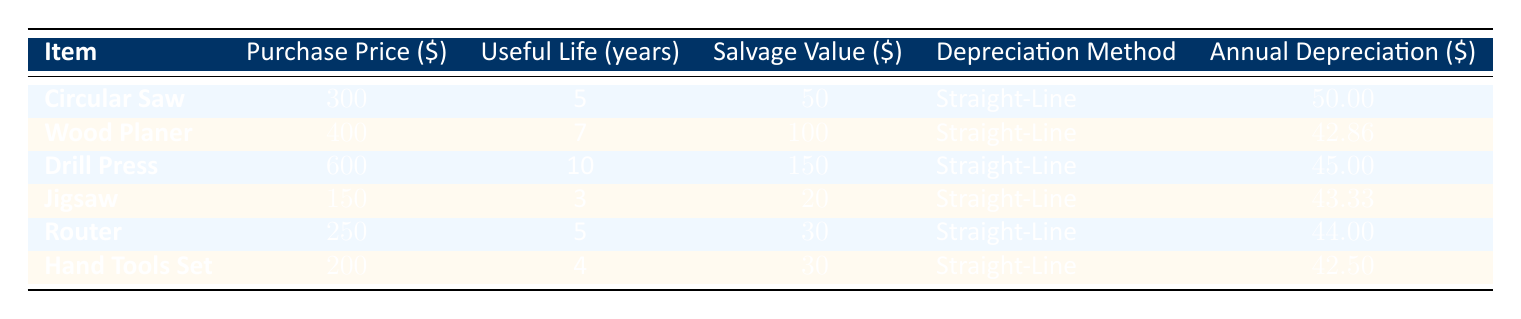What is the purchase price of the Circular Saw? The table lists the Circular Saw under the "Item" column with its corresponding information. The purchase price is provided in the "Purchase Price" column, which shows 300.
Answer: 300 What is the useful life of the Wood Planer? The Wood Planer is listed in the table, and its useful life can be found in the "Useful Life" column, which indicates a value of 7 years.
Answer: 7 years Which item has the highest annual depreciation? To determine the item with the highest annual depreciation, we compare the values in the "Annual Depreciation" column. The Circular Saw has an annual depreciation of 50, which is the highest among the listed items.
Answer: Circular Saw Is the salvage value of the Drill Press more than its annual depreciation? The salvage value of the Drill Press is 150, while its annual depreciation is 45. Since 150 is greater than 45, the statement is true.
Answer: Yes What is the total annual depreciation of all the tools and equipment? To find the total annual depreciation, we sum all the values in the "Annual Depreciation" column: 50 + 42.86 + 45 + 43.33 + 44 + 42.5 = 268.69. Thus, the total annual depreciation is 268.69.
Answer: 268.69 Which tool has the shortest useful life, and what is that duration? By examining the "Useful Life" column, the Jigsaw has the shortest useful life at 3 years, making it the item with the least duration.
Answer: Jigsaw, 3 years What would be the averaged annual depreciation of the tools? To find the average annual depreciation, we take the total annual depreciation of 268.69 and divide it by the number of items (6): 268.69 / 6 = approximately 44.78.
Answer: 44.78 Does the Router have a shorter useful life than the Hand Tools Set? The Router has a useful life of 5 years while the Hand Tools Set has a useful life of 4 years. Since the Router's life is longer, the statement is false.
Answer: No What is the combined purchase price of the Drill Press and the Jigsaw? To find the combined purchase price, we take the purchase prices of the Drill Press (600) and Jigsaw (150) and add them together: 600 + 150 = 750.
Answer: 750 